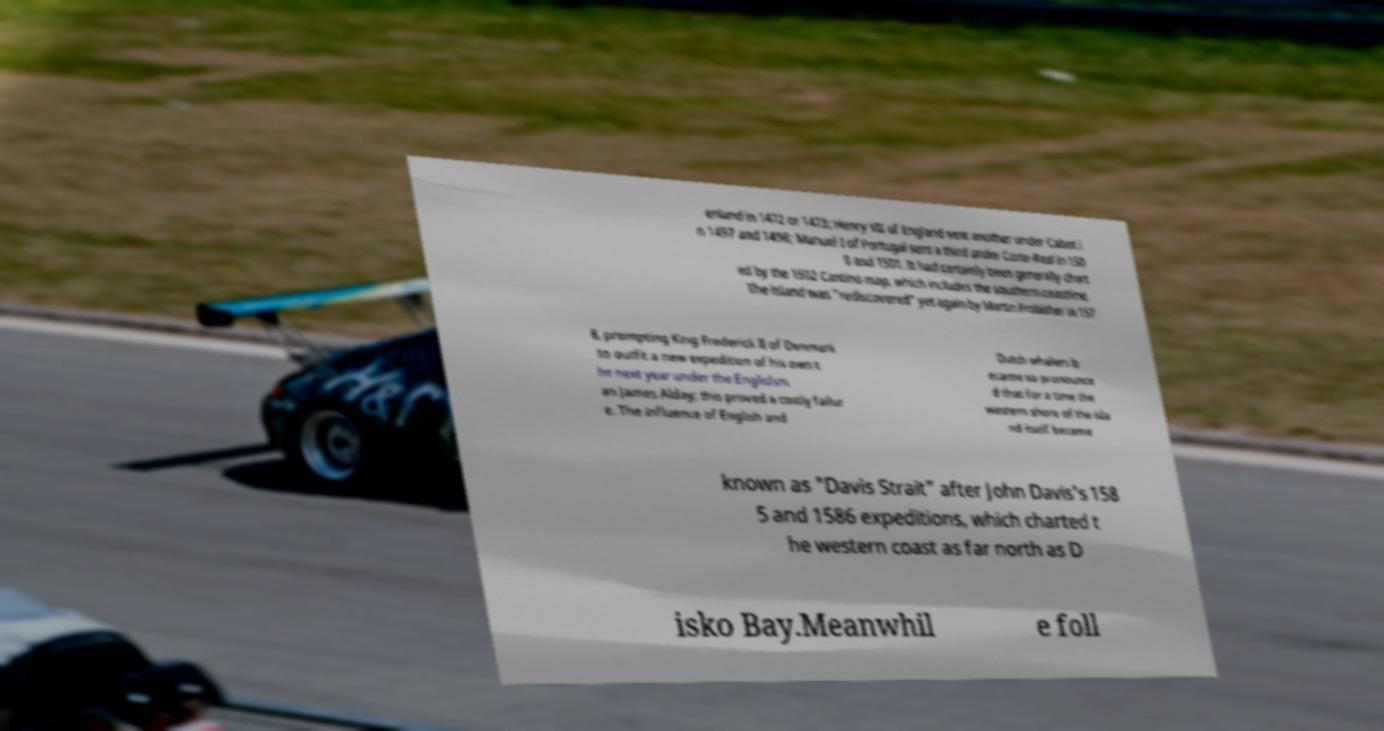Can you accurately transcribe the text from the provided image for me? enland in 1472 or 1473; Henry VII of England sent another under Cabot i n 1497 and 1498; Manuel I of Portugal sent a third under Corte-Real in 150 0 and 1501. It had certainly been generally chart ed by the 1502 Cantino map, which includes the southern coastline. The island was "rediscovered" yet again by Martin Frobisher in 157 8, prompting King Frederick II of Denmark to outfit a new expedition of his own t he next year under the Englishm an James Alday; this proved a costly failur e. The influence of English and Dutch whalers b ecame so pronounce d that for a time the western shore of the isla nd itself became known as "Davis Strait" after John Davis's 158 5 and 1586 expeditions, which charted t he western coast as far north as D isko Bay.Meanwhil e foll 